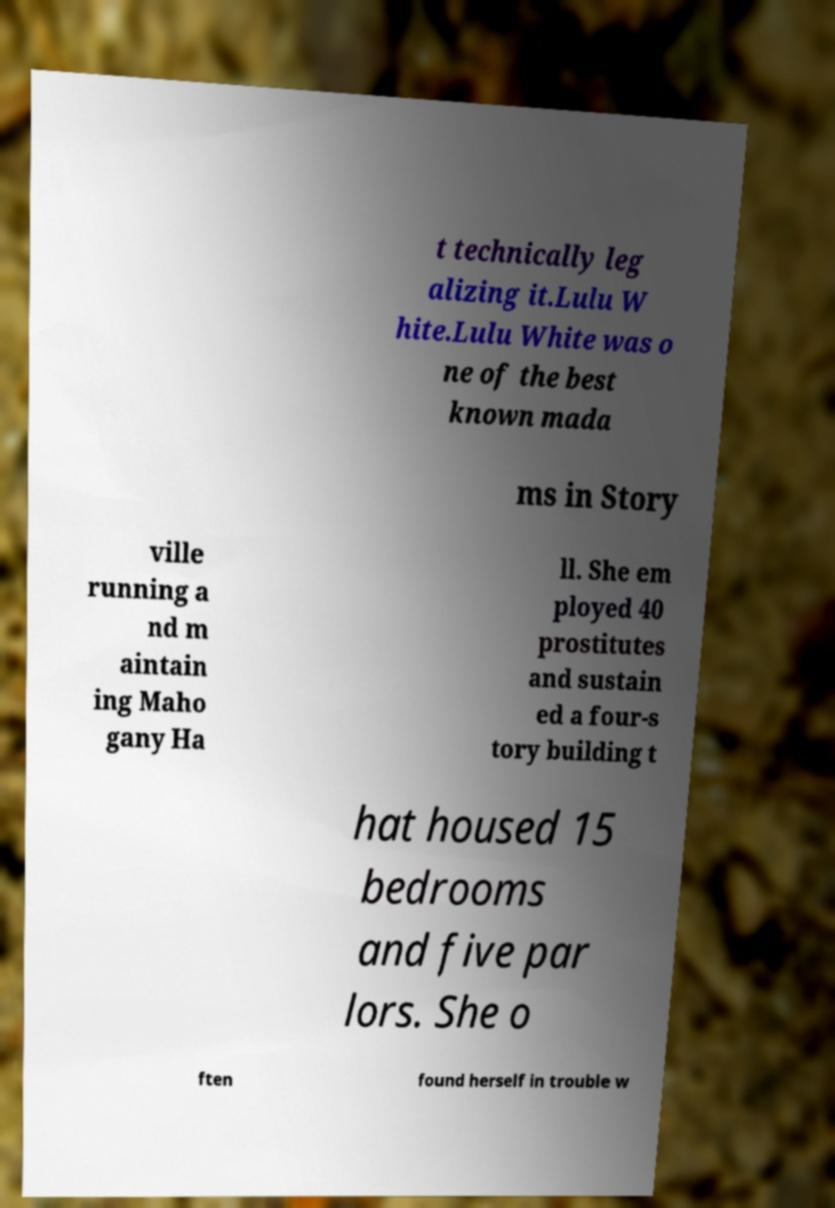What messages or text are displayed in this image? I need them in a readable, typed format. t technically leg alizing it.Lulu W hite.Lulu White was o ne of the best known mada ms in Story ville running a nd m aintain ing Maho gany Ha ll. She em ployed 40 prostitutes and sustain ed a four-s tory building t hat housed 15 bedrooms and five par lors. She o ften found herself in trouble w 